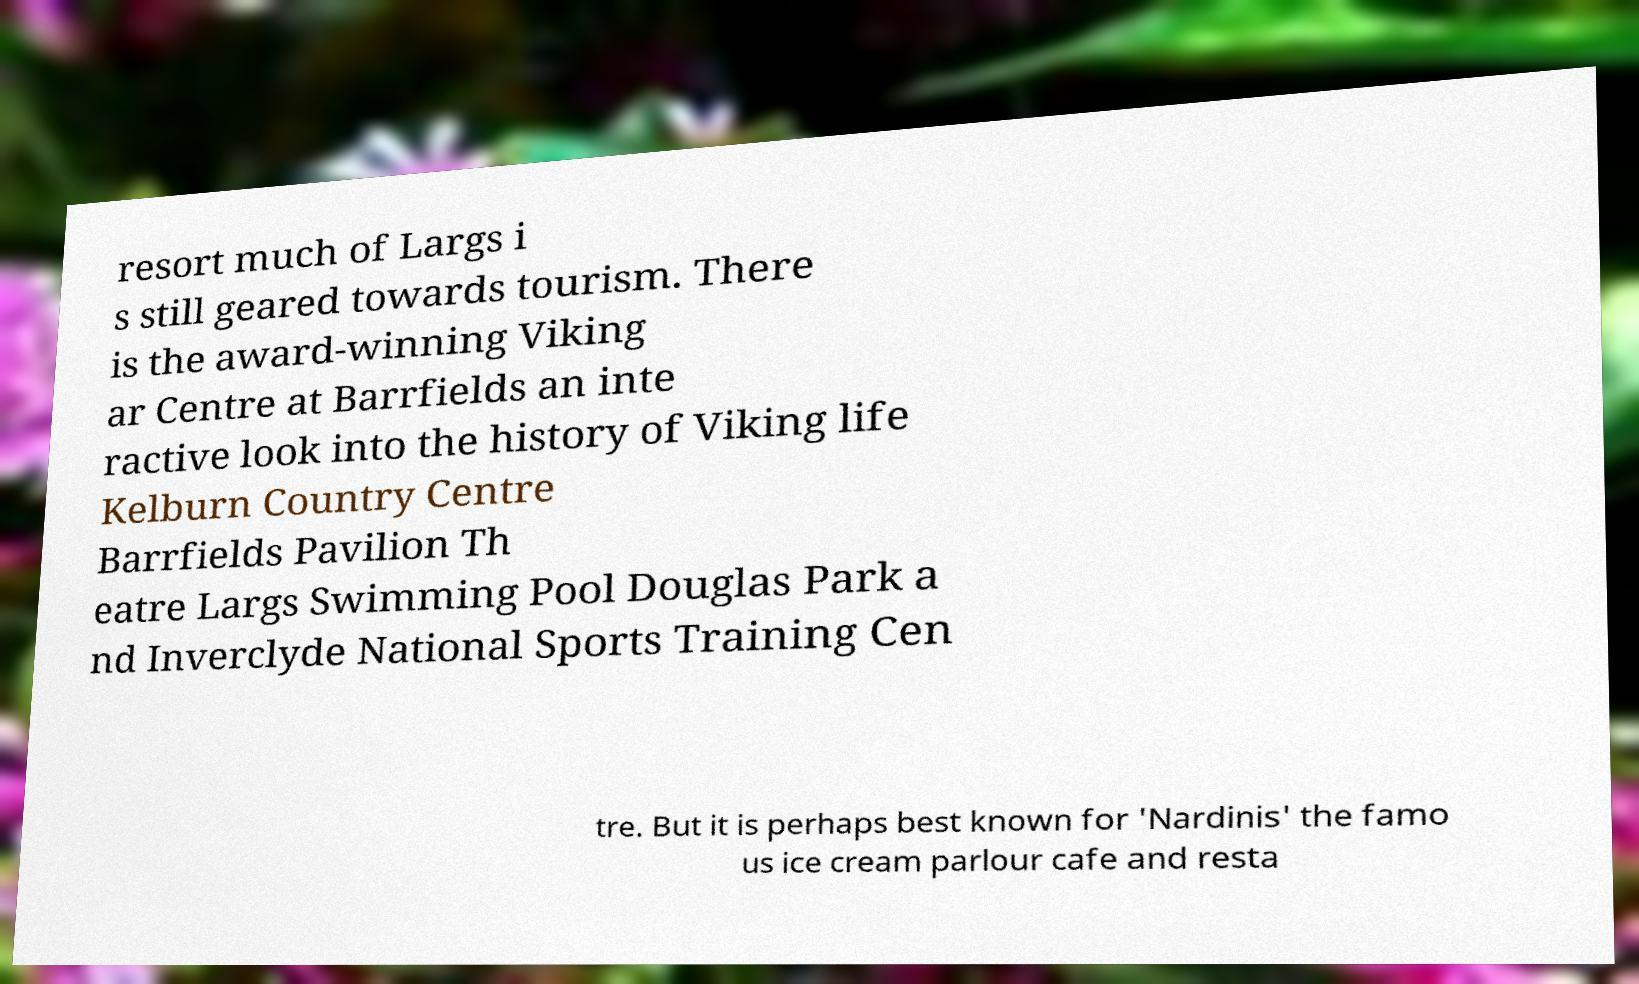Please identify and transcribe the text found in this image. resort much of Largs i s still geared towards tourism. There is the award-winning Viking ar Centre at Barrfields an inte ractive look into the history of Viking life Kelburn Country Centre Barrfields Pavilion Th eatre Largs Swimming Pool Douglas Park a nd Inverclyde National Sports Training Cen tre. But it is perhaps best known for 'Nardinis' the famo us ice cream parlour cafe and resta 